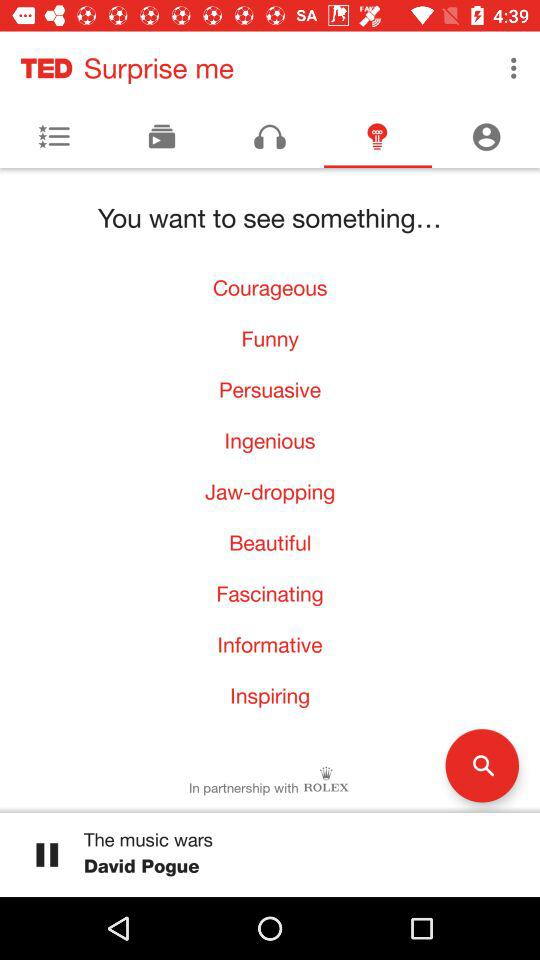Who is the speaker of "The music wars"? The speaker of "The music wars" is David Pogue. 